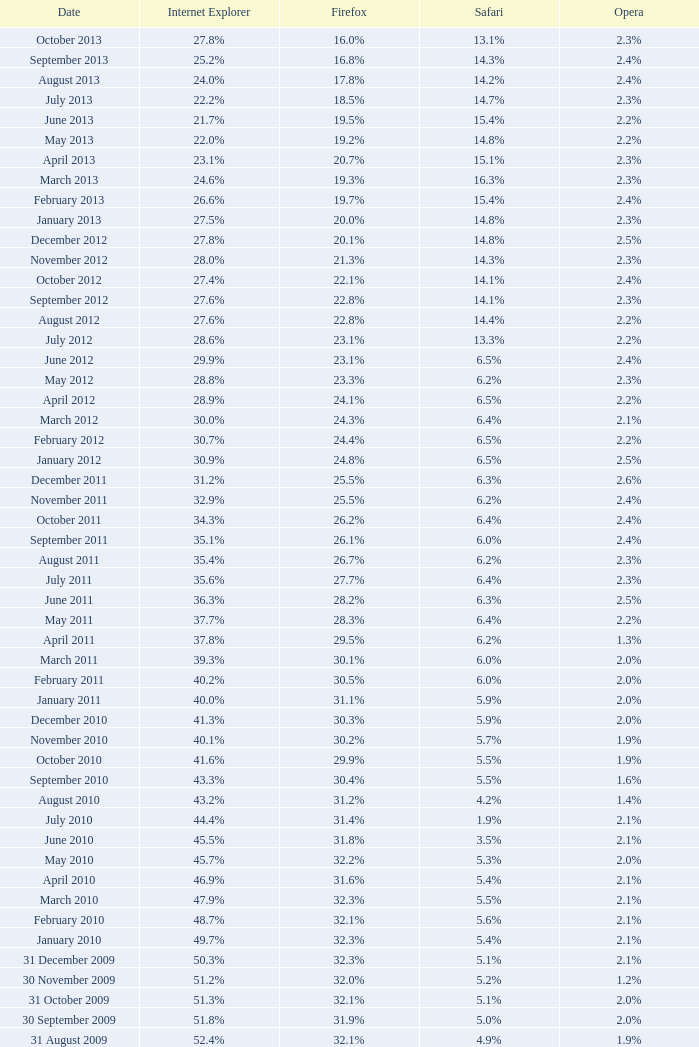0% internet explorer? 19.2%. 